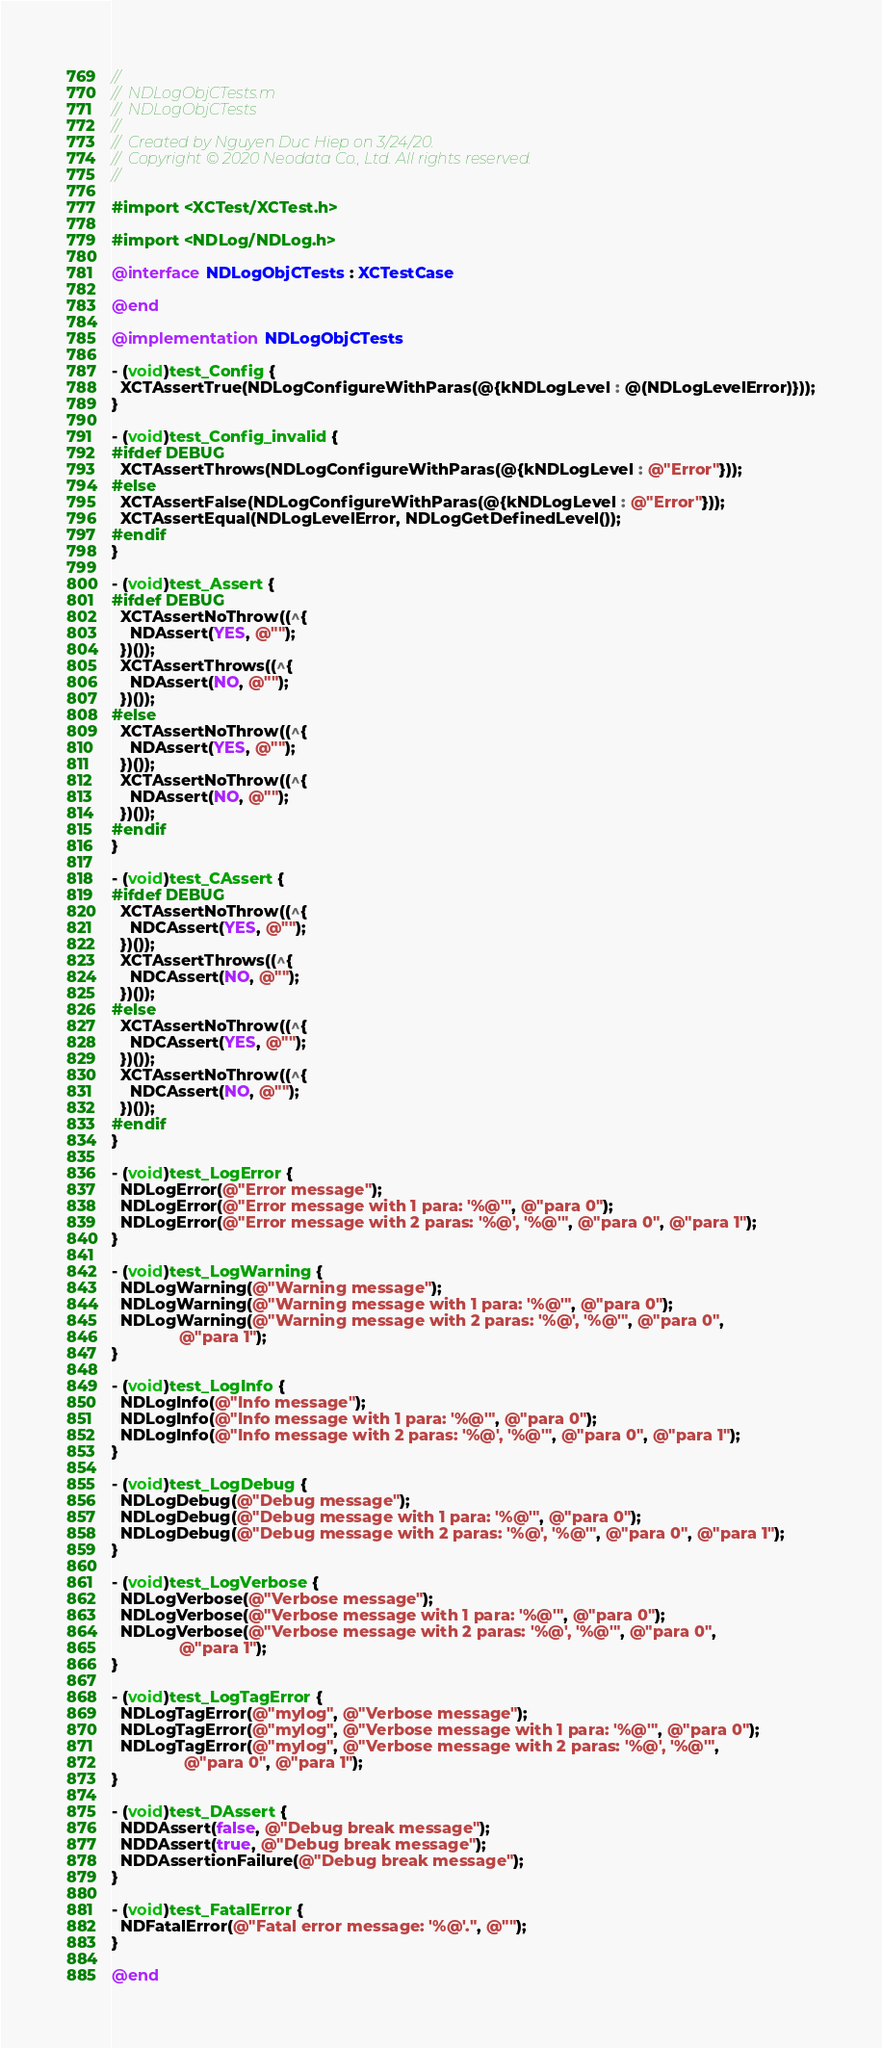Convert code to text. <code><loc_0><loc_0><loc_500><loc_500><_ObjectiveC_>//
//  NDLogObjCTests.m
//  NDLogObjCTests
//
//  Created by Nguyen Duc Hiep on 3/24/20.
//  Copyright © 2020 Neodata Co., Ltd. All rights reserved.
//

#import <XCTest/XCTest.h>

#import <NDLog/NDLog.h>

@interface NDLogObjCTests : XCTestCase

@end

@implementation NDLogObjCTests

- (void)test_Config {
  XCTAssertTrue(NDLogConfigureWithParas(@{kNDLogLevel : @(NDLogLevelError)}));
}

- (void)test_Config_invalid {
#ifdef DEBUG
  XCTAssertThrows(NDLogConfigureWithParas(@{kNDLogLevel : @"Error"}));
#else
  XCTAssertFalse(NDLogConfigureWithParas(@{kNDLogLevel : @"Error"}));
  XCTAssertEqual(NDLogLevelError, NDLogGetDefinedLevel());
#endif
}

- (void)test_Assert {
#ifdef DEBUG
  XCTAssertNoThrow((^{
    NDAssert(YES, @"");
  })());
  XCTAssertThrows((^{
    NDAssert(NO, @"");
  })());
#else
  XCTAssertNoThrow((^{
    NDAssert(YES, @"");
  })());
  XCTAssertNoThrow((^{
    NDAssert(NO, @"");
  })());
#endif
}

- (void)test_CAssert {
#ifdef DEBUG
  XCTAssertNoThrow((^{
    NDCAssert(YES, @"");
  })());
  XCTAssertThrows((^{
    NDCAssert(NO, @"");
  })());
#else
  XCTAssertNoThrow((^{
    NDCAssert(YES, @"");
  })());
  XCTAssertNoThrow((^{
    NDCAssert(NO, @"");
  })());
#endif
}

- (void)test_LogError {
  NDLogError(@"Error message");
  NDLogError(@"Error message with 1 para: '%@'", @"para 0");
  NDLogError(@"Error message with 2 paras: '%@', '%@'", @"para 0", @"para 1");
}

- (void)test_LogWarning {
  NDLogWarning(@"Warning message");
  NDLogWarning(@"Warning message with 1 para: '%@'", @"para 0");
  NDLogWarning(@"Warning message with 2 paras: '%@', '%@'", @"para 0",
               @"para 1");
}

- (void)test_LogInfo {
  NDLogInfo(@"Info message");
  NDLogInfo(@"Info message with 1 para: '%@'", @"para 0");
  NDLogInfo(@"Info message with 2 paras: '%@', '%@'", @"para 0", @"para 1");
}

- (void)test_LogDebug {
  NDLogDebug(@"Debug message");
  NDLogDebug(@"Debug message with 1 para: '%@'", @"para 0");
  NDLogDebug(@"Debug message with 2 paras: '%@', '%@'", @"para 0", @"para 1");
}

- (void)test_LogVerbose {
  NDLogVerbose(@"Verbose message");
  NDLogVerbose(@"Verbose message with 1 para: '%@'", @"para 0");
  NDLogVerbose(@"Verbose message with 2 paras: '%@', '%@'", @"para 0",
               @"para 1");
}

- (void)test_LogTagError {
  NDLogTagError(@"mylog", @"Verbose message");
  NDLogTagError(@"mylog", @"Verbose message with 1 para: '%@'", @"para 0");
  NDLogTagError(@"mylog", @"Verbose message with 2 paras: '%@', '%@'",
                @"para 0", @"para 1");
}

- (void)test_DAssert {
  NDDAssert(false, @"Debug break message");
  NDDAssert(true, @"Debug break message");
  NDDAssertionFailure(@"Debug break message");
}

- (void)test_FatalError {
  NDFatalError(@"Fatal error message: '%@'.", @"");
}

@end
</code> 